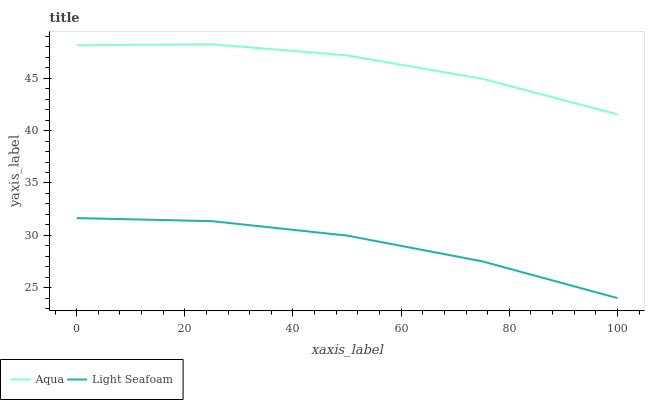Does Light Seafoam have the minimum area under the curve?
Answer yes or no. Yes. Does Aqua have the maximum area under the curve?
Answer yes or no. Yes. Does Aqua have the minimum area under the curve?
Answer yes or no. No. Is Light Seafoam the smoothest?
Answer yes or no. Yes. Is Aqua the roughest?
Answer yes or no. Yes. Is Aqua the smoothest?
Answer yes or no. No. Does Aqua have the lowest value?
Answer yes or no. No. Does Aqua have the highest value?
Answer yes or no. Yes. Is Light Seafoam less than Aqua?
Answer yes or no. Yes. Is Aqua greater than Light Seafoam?
Answer yes or no. Yes. Does Light Seafoam intersect Aqua?
Answer yes or no. No. 